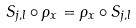<formula> <loc_0><loc_0><loc_500><loc_500>S _ { j , l } \circ \rho _ { x } = \rho _ { x } \circ S _ { j , l }</formula> 